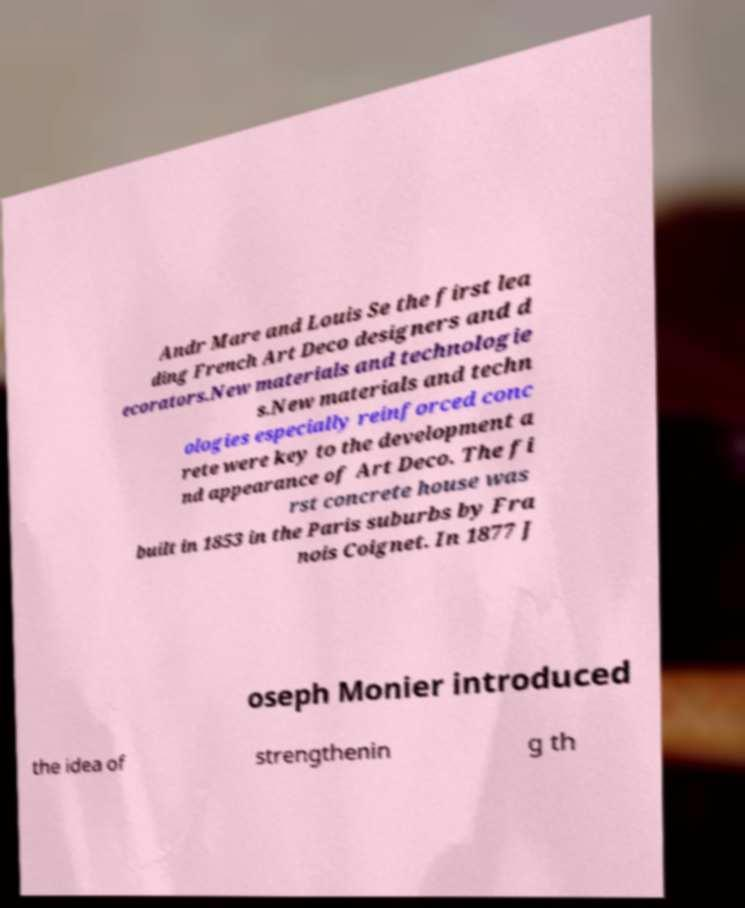Could you extract and type out the text from this image? Andr Mare and Louis Se the first lea ding French Art Deco designers and d ecorators.New materials and technologie s.New materials and techn ologies especially reinforced conc rete were key to the development a nd appearance of Art Deco. The fi rst concrete house was built in 1853 in the Paris suburbs by Fra nois Coignet. In 1877 J oseph Monier introduced the idea of strengthenin g th 